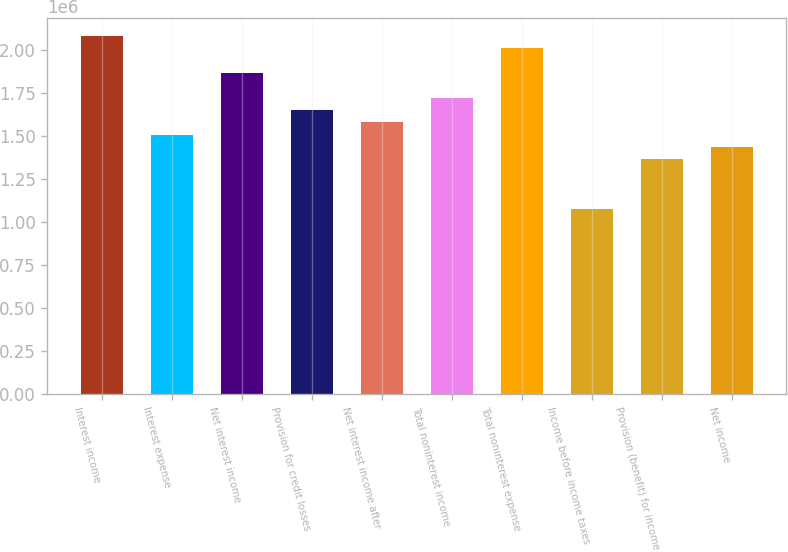Convert chart to OTSL. <chart><loc_0><loc_0><loc_500><loc_500><bar_chart><fcel>Interest income<fcel>Interest expense<fcel>Net interest income<fcel>Provision for credit losses<fcel>Net interest income after<fcel>Total noninterest income<fcel>Total noninterest expense<fcel>Income before income taxes<fcel>Provision (benefit) for income<fcel>Net income<nl><fcel>2.08392e+06<fcel>1.50905e+06<fcel>1.86834e+06<fcel>1.65276e+06<fcel>1.5809e+06<fcel>1.72462e+06<fcel>2.01206e+06<fcel>1.07789e+06<fcel>1.36533e+06<fcel>1.43719e+06<nl></chart> 